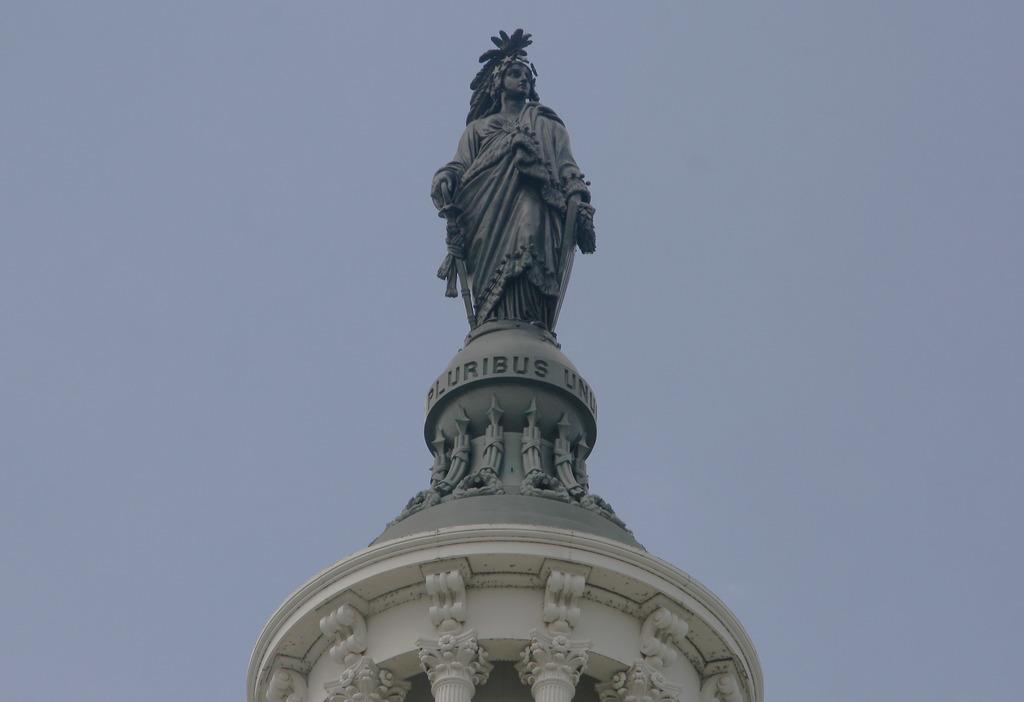What is the main subject in the image? There is a statue in the image. What can be seen in the background of the image? The sky is visible in the background of the image. How does the statue care for the waves in the image? The image does not depict any waves or the act of caring for them. The statue is a stationary object, and there is no indication of it performing any actions in the image. 